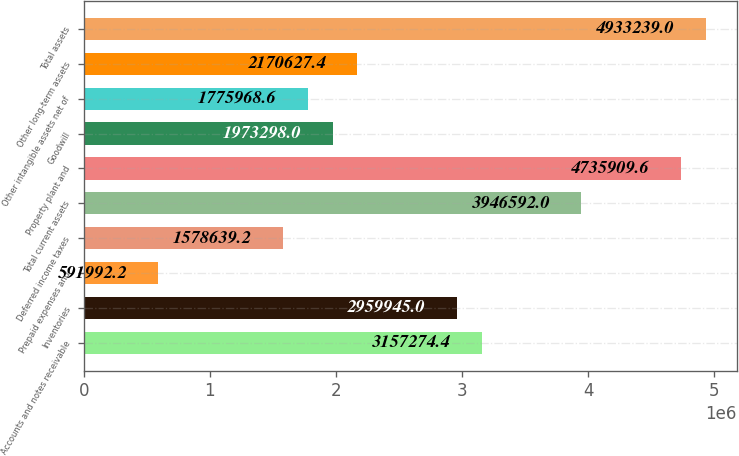<chart> <loc_0><loc_0><loc_500><loc_500><bar_chart><fcel>Accounts and notes receivable<fcel>Inventories<fcel>Prepaid expenses and<fcel>Deferred income taxes<fcel>Total current assets<fcel>Property plant and<fcel>Goodwill<fcel>Other intangible assets net of<fcel>Other long-term assets<fcel>Total assets<nl><fcel>3.15727e+06<fcel>2.95994e+06<fcel>591992<fcel>1.57864e+06<fcel>3.94659e+06<fcel>4.73591e+06<fcel>1.9733e+06<fcel>1.77597e+06<fcel>2.17063e+06<fcel>4.93324e+06<nl></chart> 